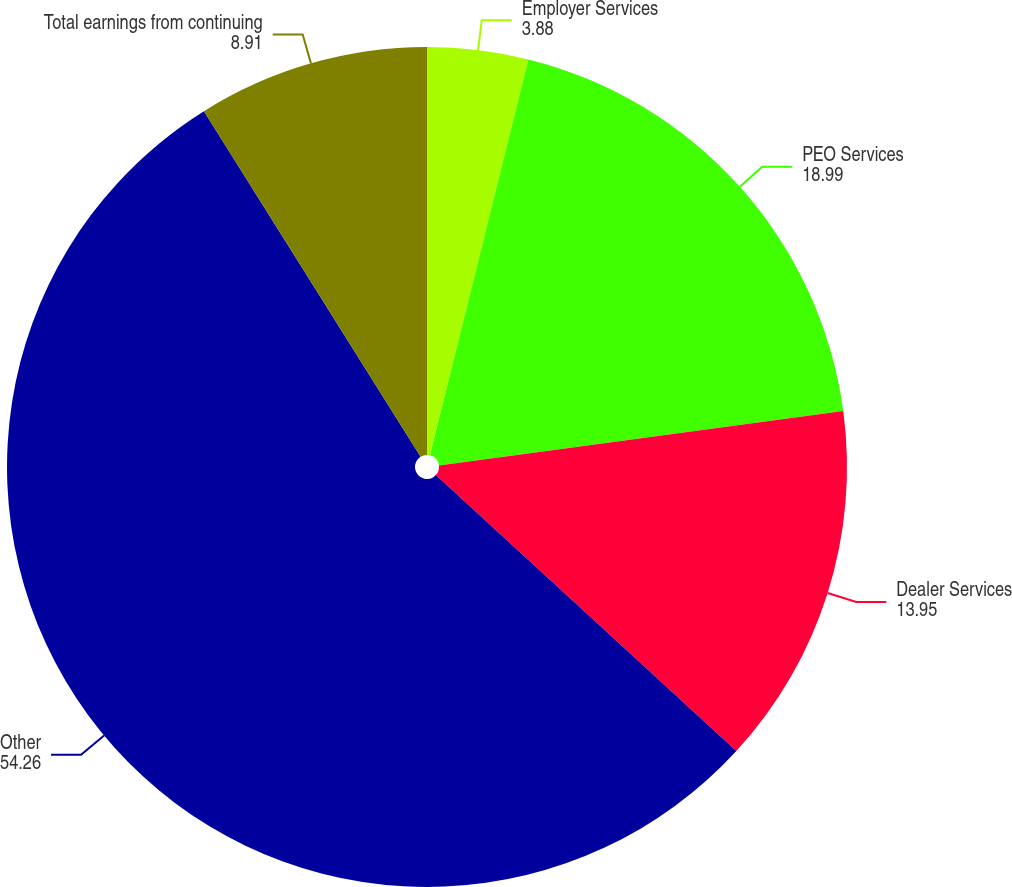Convert chart. <chart><loc_0><loc_0><loc_500><loc_500><pie_chart><fcel>Employer Services<fcel>PEO Services<fcel>Dealer Services<fcel>Other<fcel>Total earnings from continuing<nl><fcel>3.88%<fcel>18.99%<fcel>13.95%<fcel>54.26%<fcel>8.91%<nl></chart> 